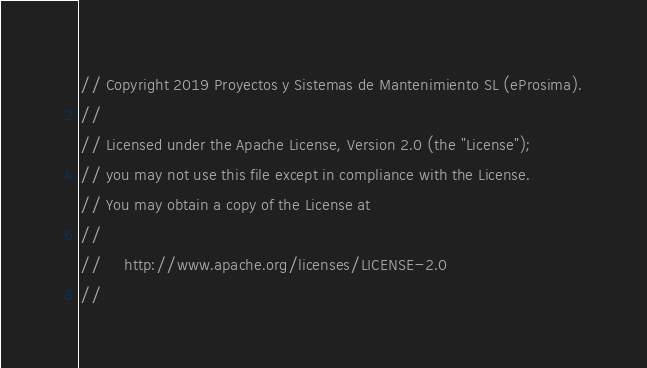<code> <loc_0><loc_0><loc_500><loc_500><_C++_>// Copyright 2019 Proyectos y Sistemas de Mantenimiento SL (eProsima).
//
// Licensed under the Apache License, Version 2.0 (the "License");
// you may not use this file except in compliance with the License.
// You may obtain a copy of the License at
//
//     http://www.apache.org/licenses/LICENSE-2.0
//</code> 